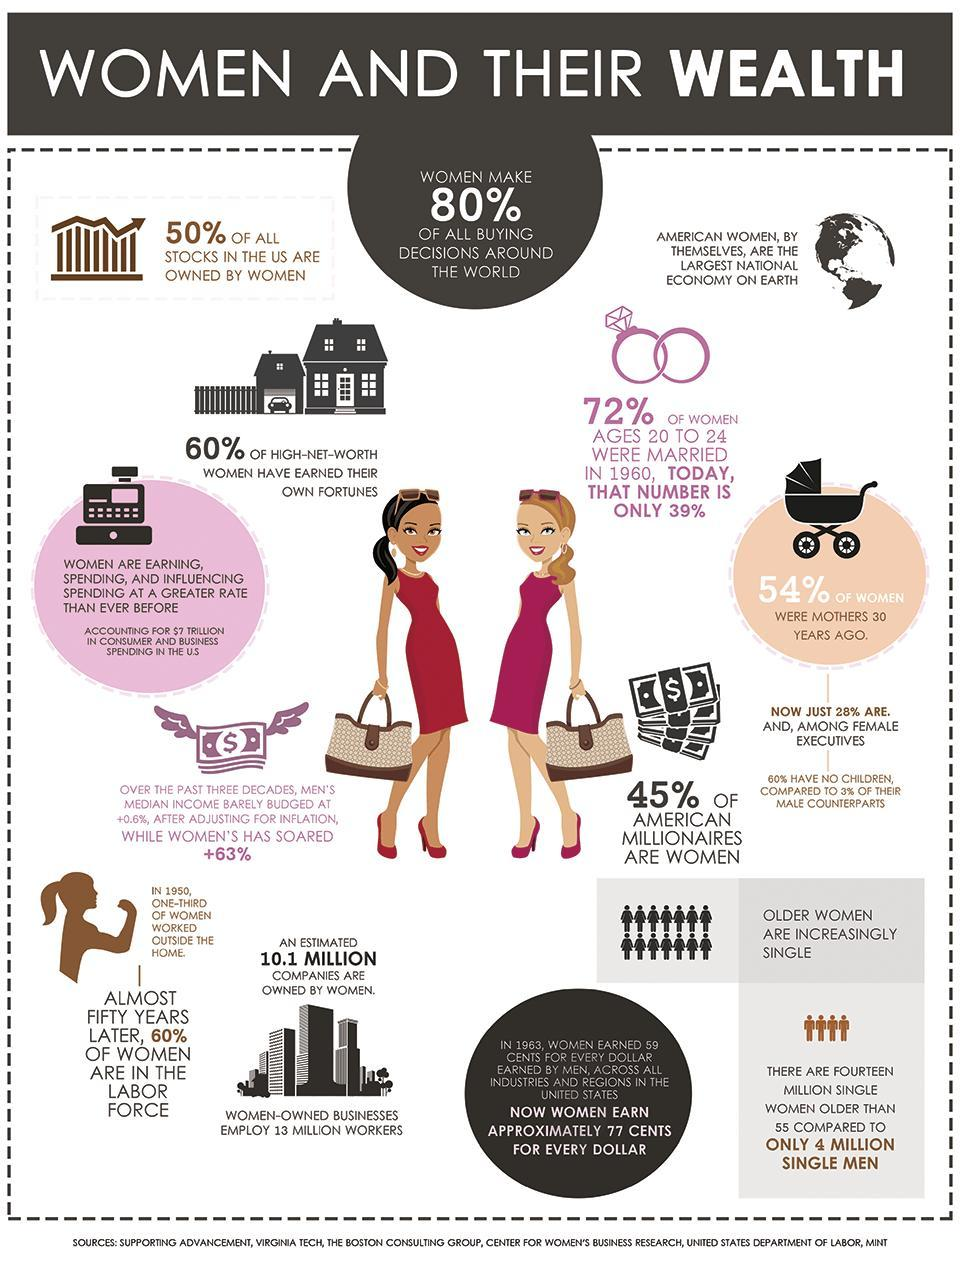What percent of men own half of all the stocks in the US?
Answer the question with a short phrase. 50% 